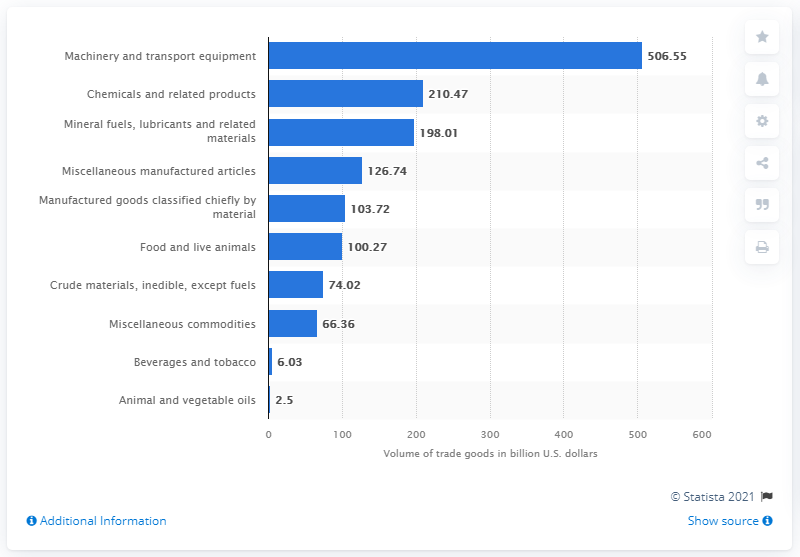Point out several critical features in this image. In 2019, the United States exported $100.27 billion worth of food and live animals in dollars. 